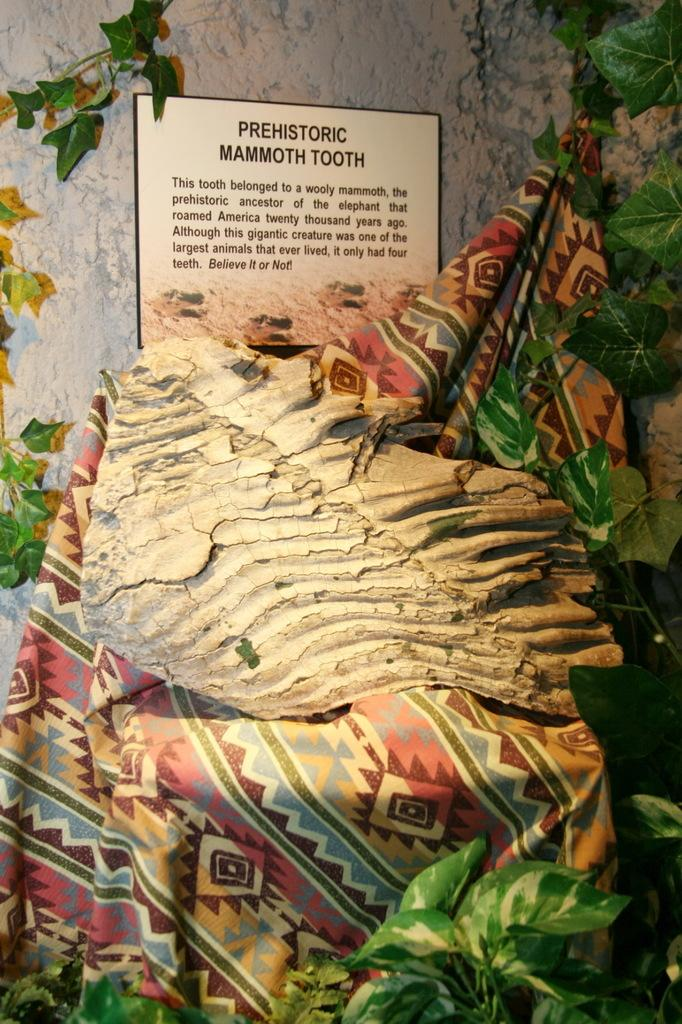What is the main object on the cloth in the image? There is an object on a cloth in the image, but the specific object is not mentioned in the facts. What type of natural elements can be seen in the image? There are leaves in the image. What is written on the board in the image? There is text written on a board in the image, but the specific text is not mentioned in the facts. What can be seen in the background of the image? There is a wall visible in the background of the image. What type of education is being provided in the image? There is no indication of education in the image; it only shows an object on a cloth, leaves, text on a board, and a wall in the background. What type of plants are visible in the image? The facts mention leaves, but they do not specify the type of plants they belong to. Is there a bath visible in the image? There is no mention of a bath or any bath-related objects in the image. 